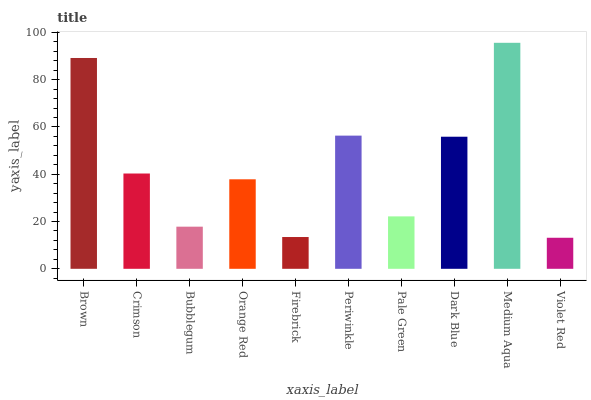Is Violet Red the minimum?
Answer yes or no. Yes. Is Medium Aqua the maximum?
Answer yes or no. Yes. Is Crimson the minimum?
Answer yes or no. No. Is Crimson the maximum?
Answer yes or no. No. Is Brown greater than Crimson?
Answer yes or no. Yes. Is Crimson less than Brown?
Answer yes or no. Yes. Is Crimson greater than Brown?
Answer yes or no. No. Is Brown less than Crimson?
Answer yes or no. No. Is Crimson the high median?
Answer yes or no. Yes. Is Orange Red the low median?
Answer yes or no. Yes. Is Violet Red the high median?
Answer yes or no. No. Is Firebrick the low median?
Answer yes or no. No. 